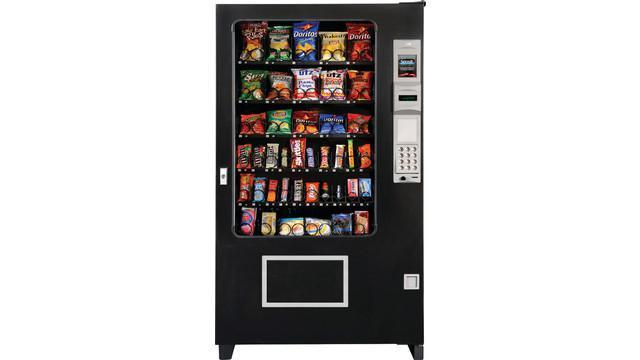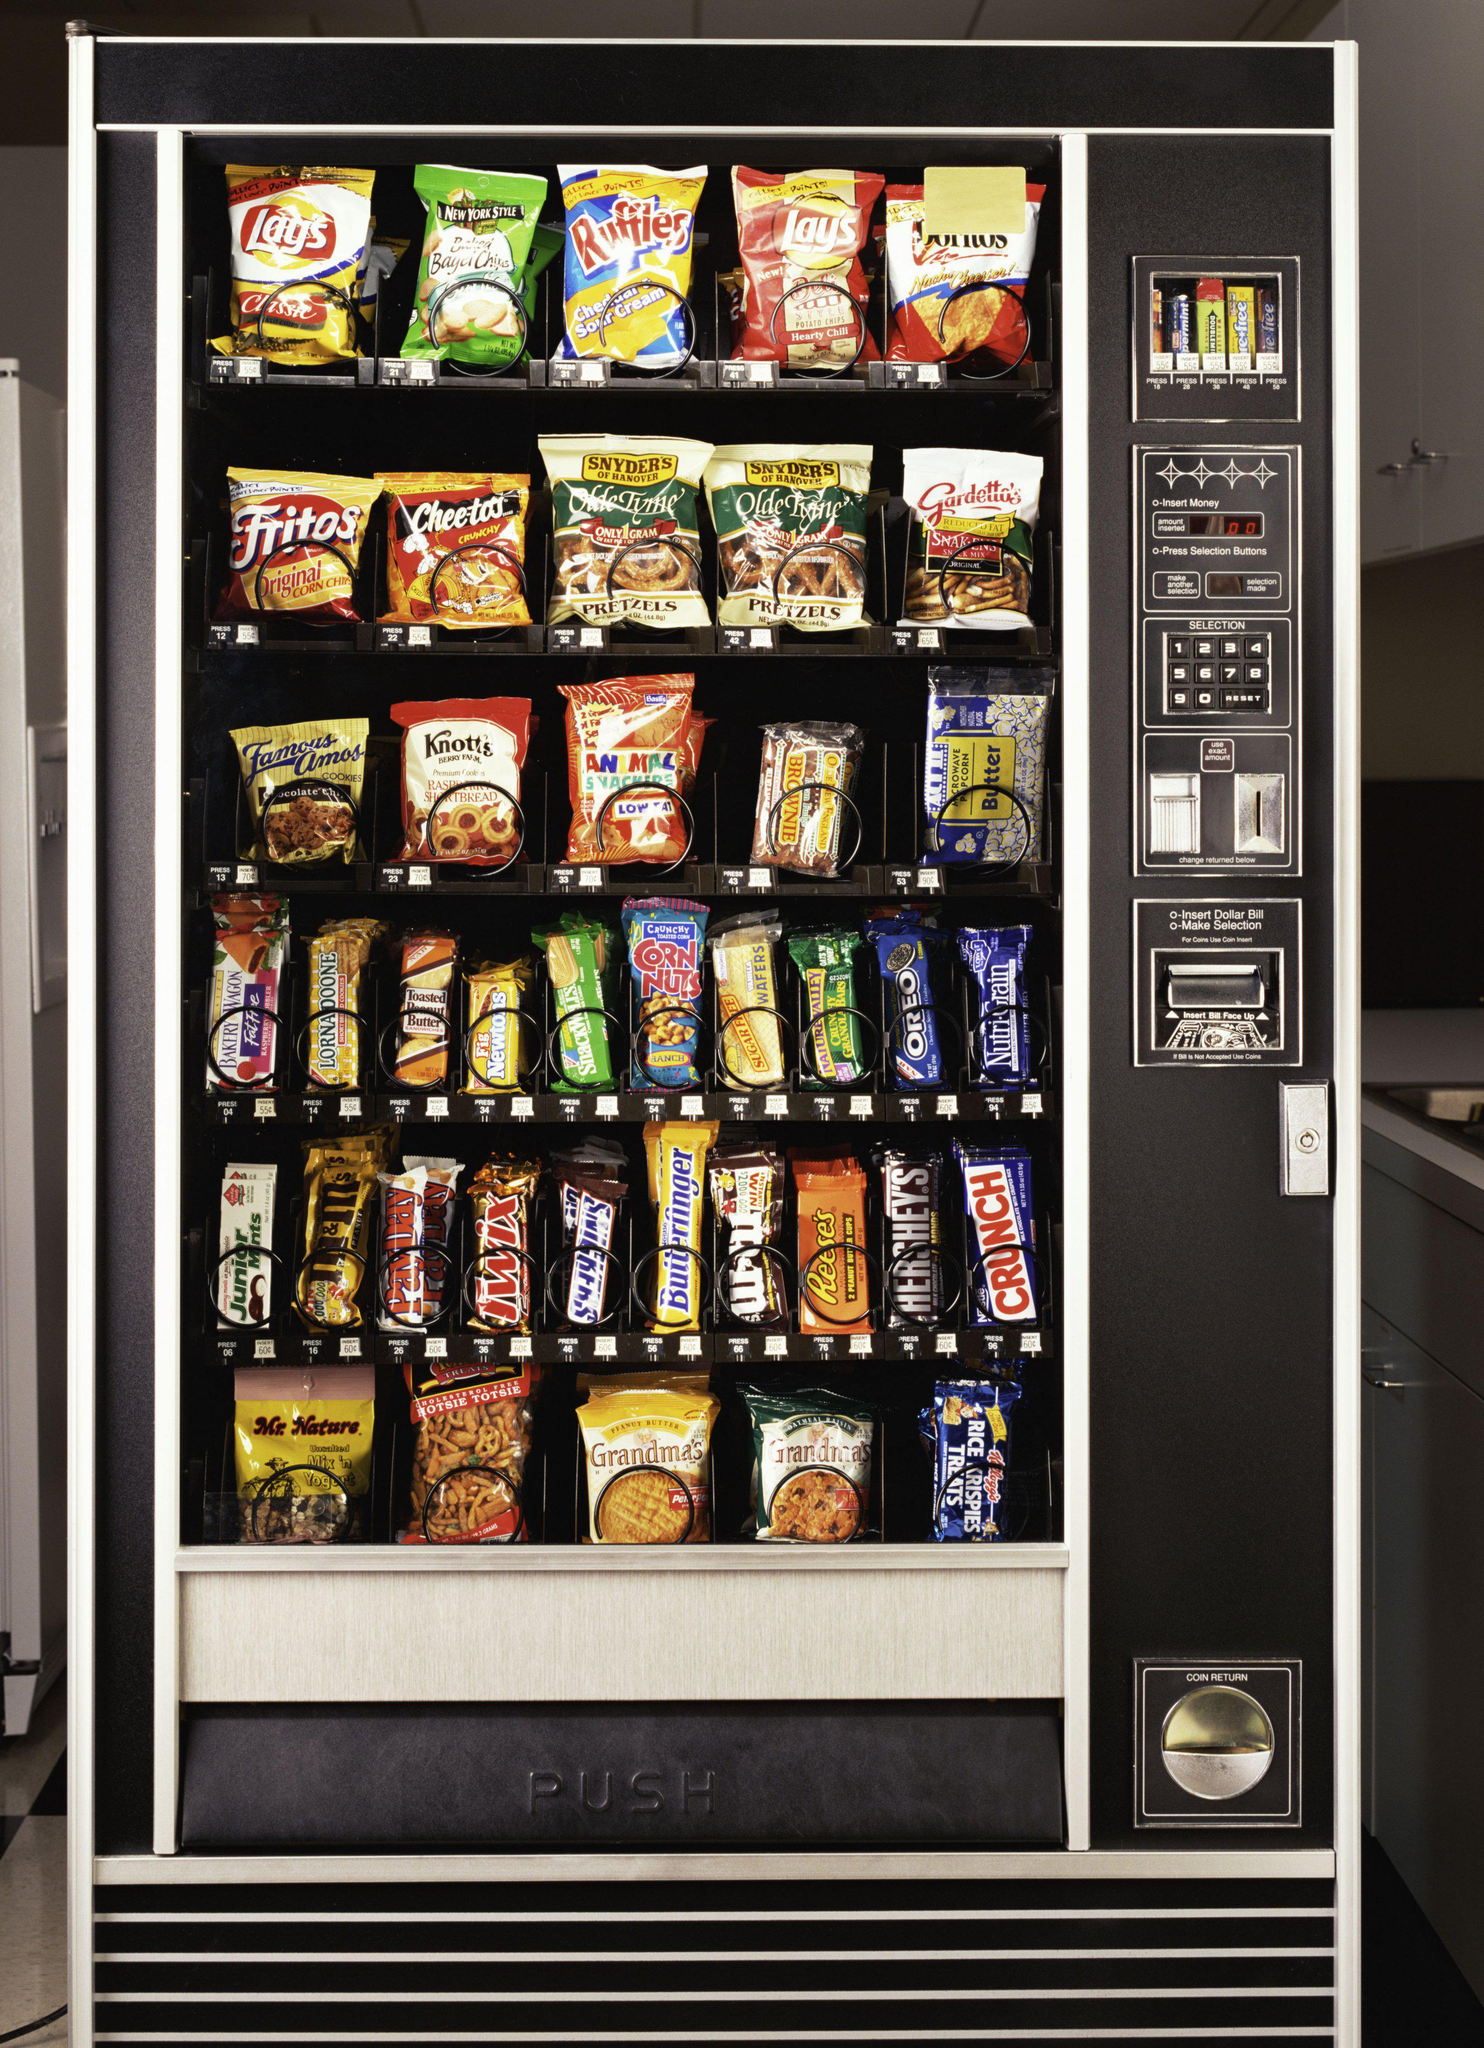The first image is the image on the left, the second image is the image on the right. Evaluate the accuracy of this statement regarding the images: "The dispensing port of the vending machine in the image on the left is outlined by a gray rectangle.". Is it true? Answer yes or no. Yes. 